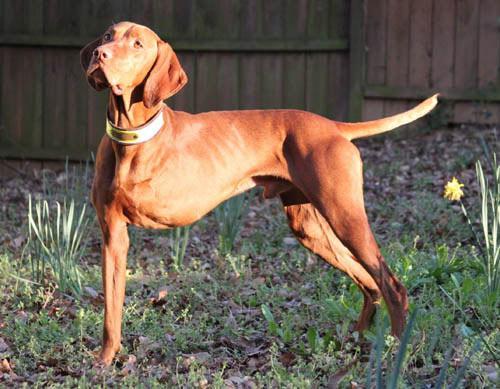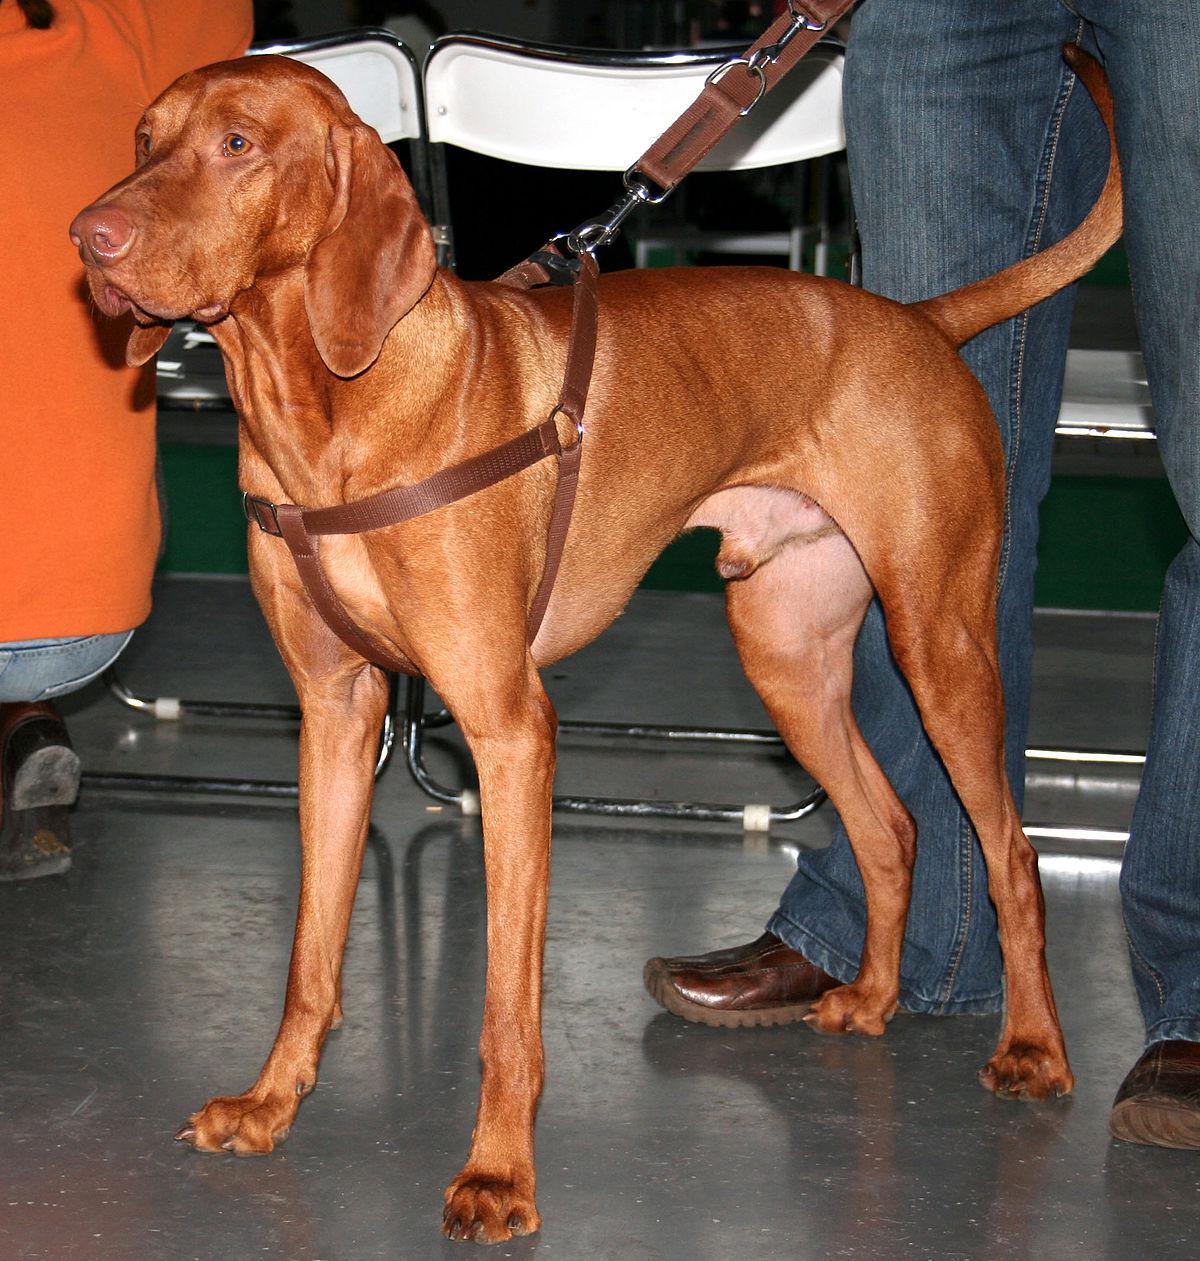The first image is the image on the left, the second image is the image on the right. Given the left and right images, does the statement "At least one dog is on a leash." hold true? Answer yes or no. Yes. The first image is the image on the left, the second image is the image on the right. For the images shown, is this caption "There are two dogs with their mouths closed." true? Answer yes or no. Yes. 